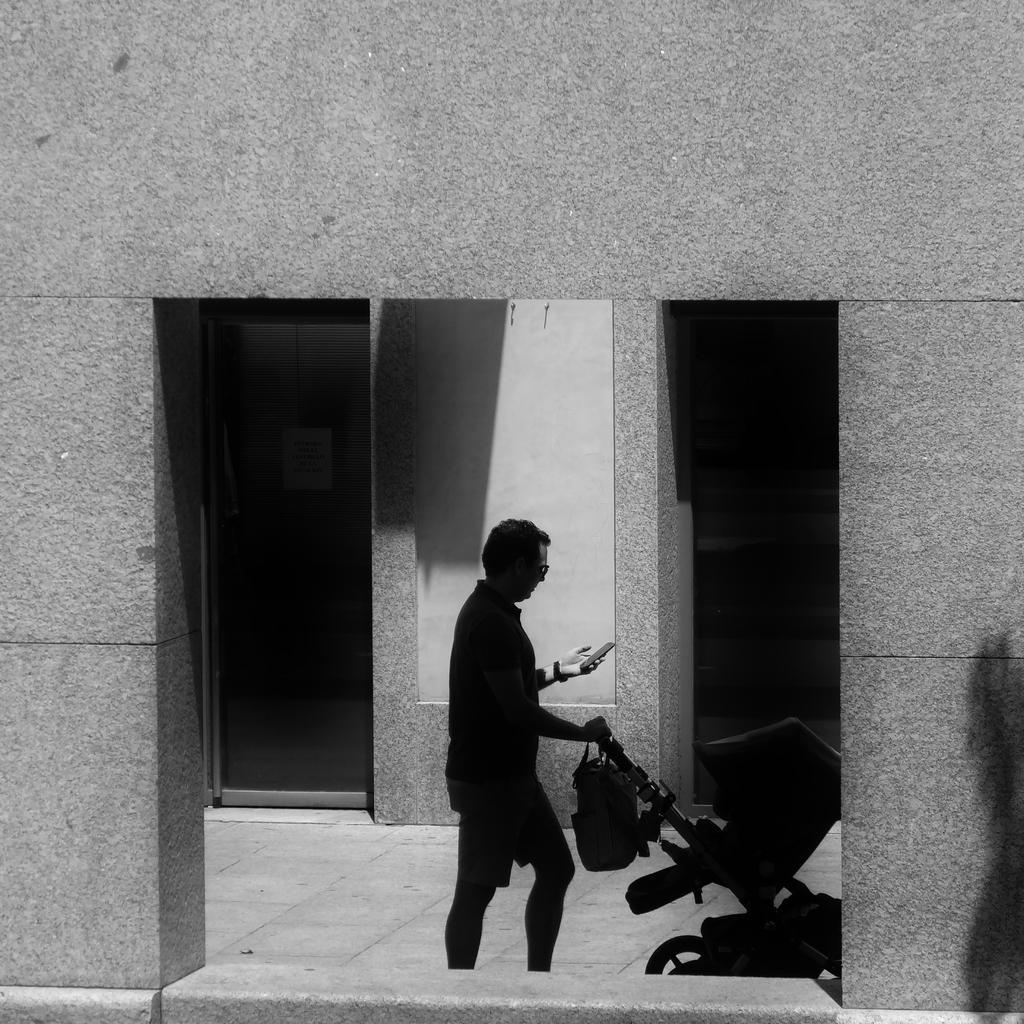Please provide a concise description of this image. This is a black and white image of a person standing and holding a stroller and a mobile, and in the background there is building. 